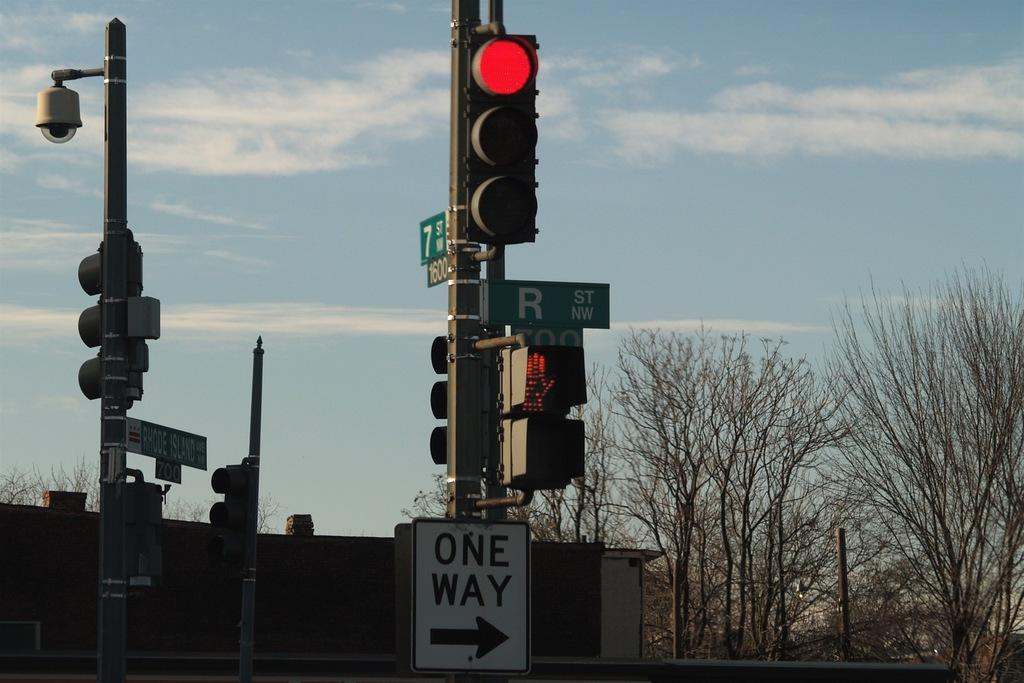<image>
Provide a brief description of the given image. A street sign name "r" on a post 